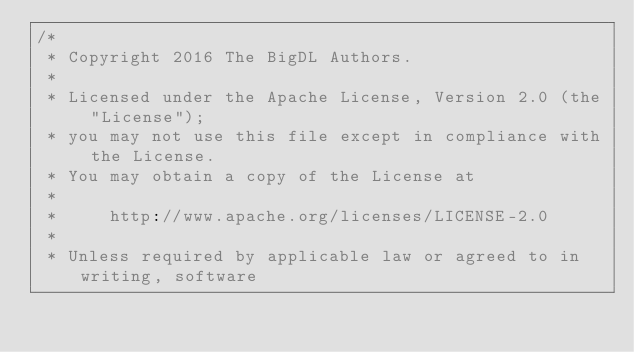Convert code to text. <code><loc_0><loc_0><loc_500><loc_500><_Scala_>/*
 * Copyright 2016 The BigDL Authors.
 *
 * Licensed under the Apache License, Version 2.0 (the "License");
 * you may not use this file except in compliance with the License.
 * You may obtain a copy of the License at
 *
 *     http://www.apache.org/licenses/LICENSE-2.0
 *
 * Unless required by applicable law or agreed to in writing, software</code> 